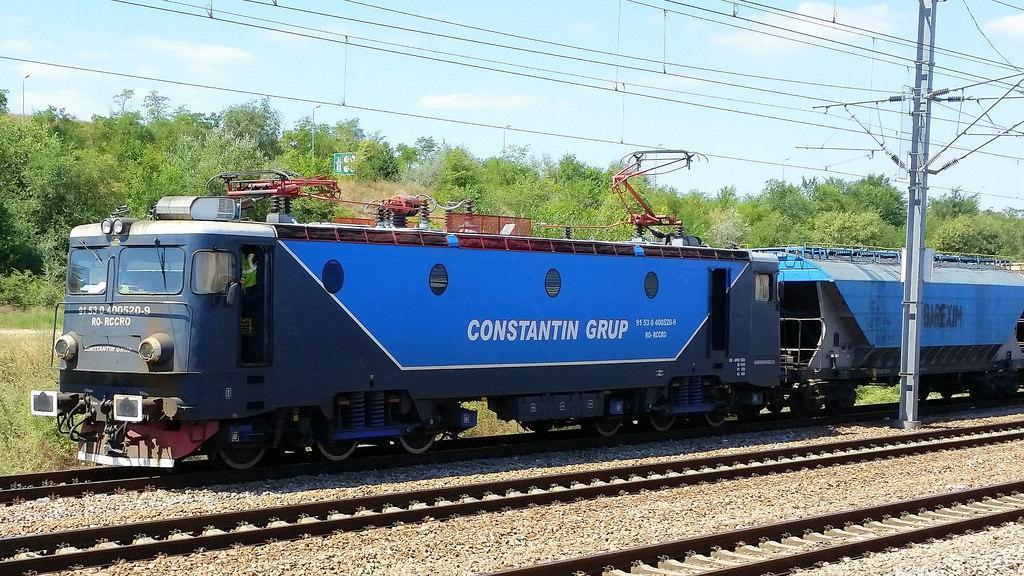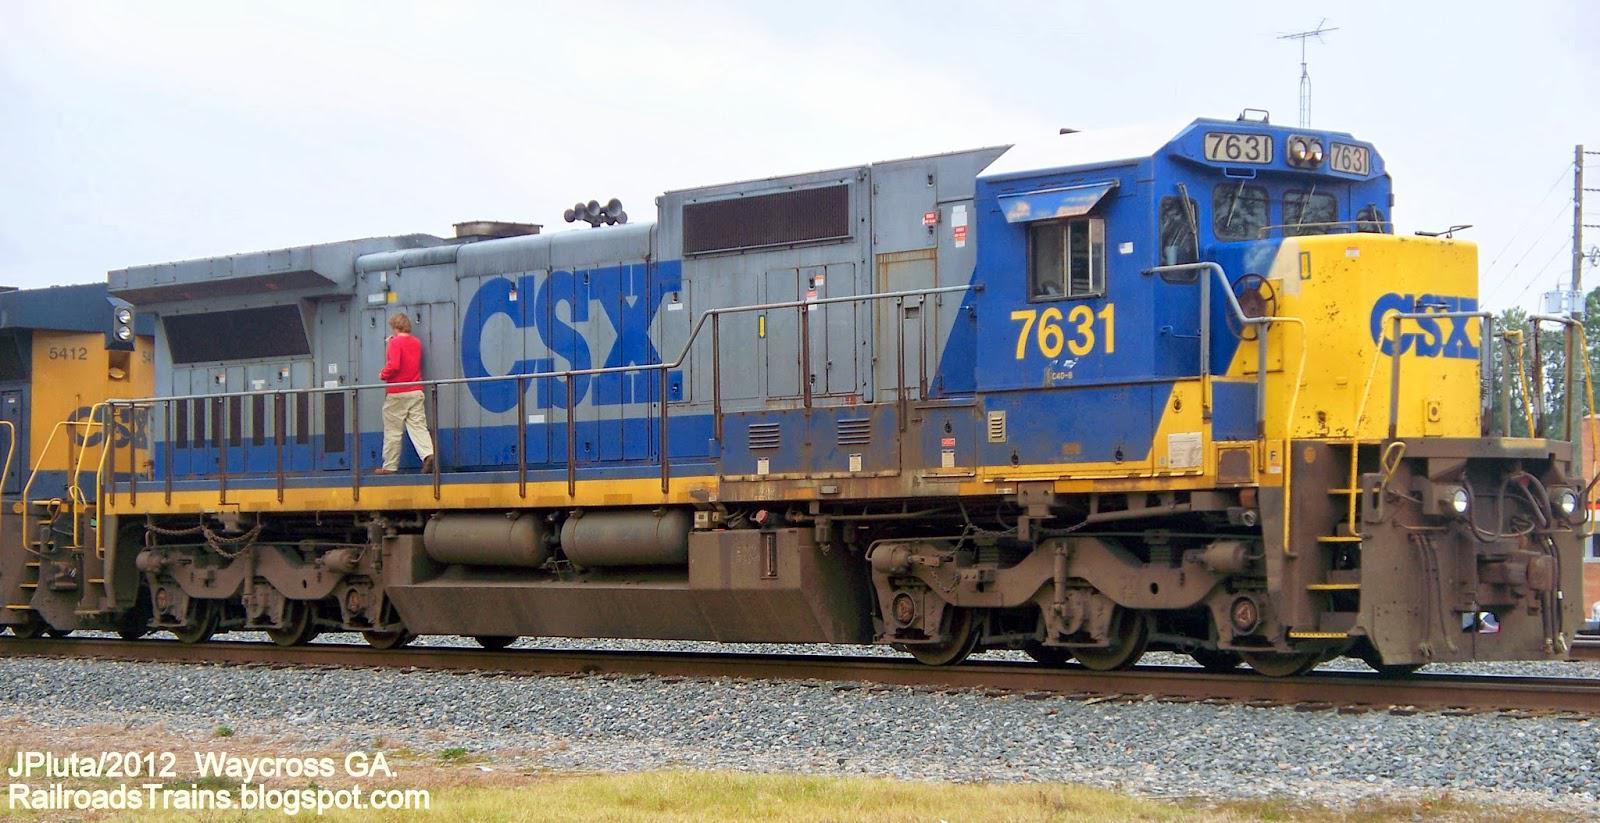The first image is the image on the left, the second image is the image on the right. Considering the images on both sides, is "1 locomotive has CSX painted on the side." valid? Answer yes or no. Yes. 